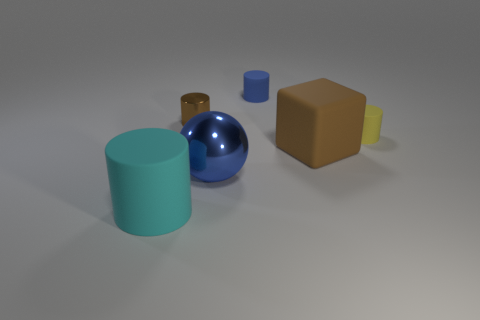Add 2 large brown matte blocks. How many objects exist? 8 Subtract all cylinders. How many objects are left? 2 Add 4 small blue matte objects. How many small blue matte objects are left? 5 Add 5 big purple rubber objects. How many big purple rubber objects exist? 5 Subtract 1 yellow cylinders. How many objects are left? 5 Subtract all yellow spheres. Subtract all cyan things. How many objects are left? 5 